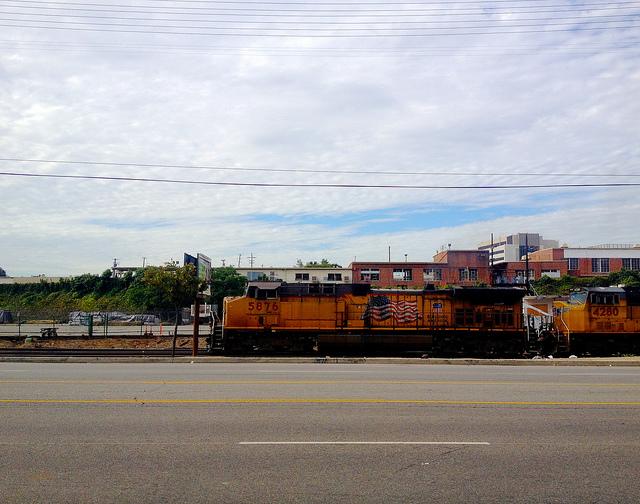Is there a turning lane?
Write a very short answer. No. Is there a bird in the sky?
Write a very short answer. No. Why can't the train cross the road?
Concise answer only. No tracks. 